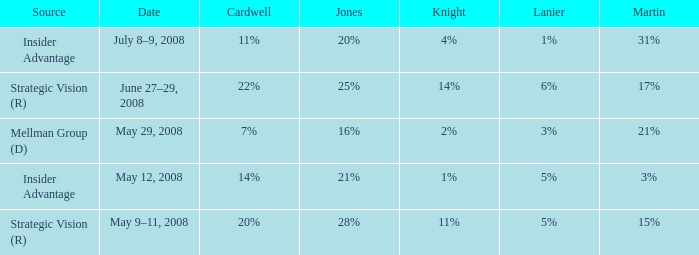What martin has a lanier of 6%? 17%. 